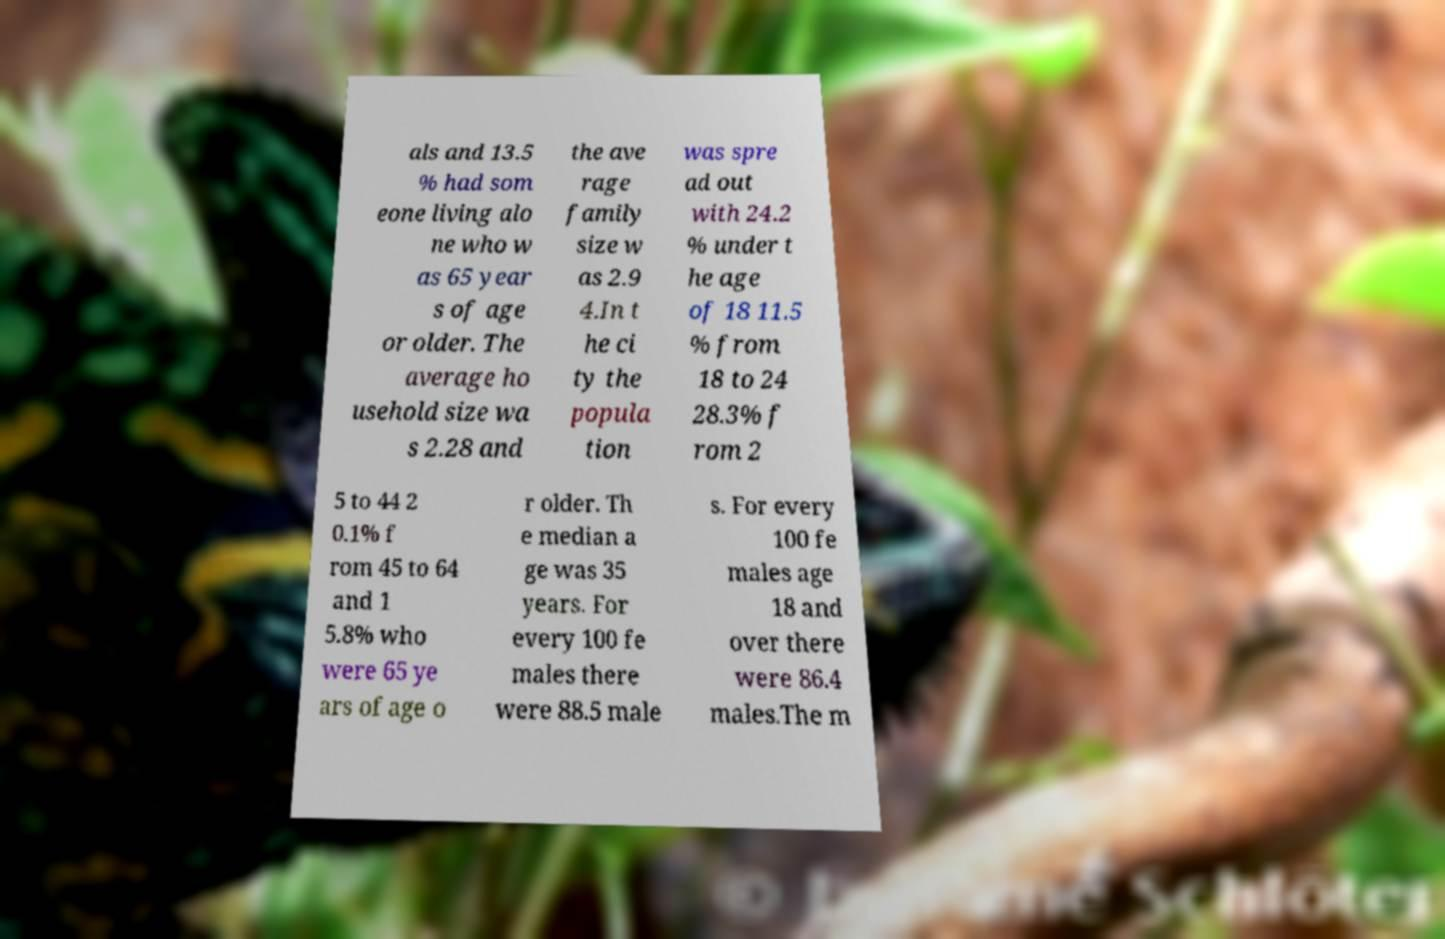Can you accurately transcribe the text from the provided image for me? als and 13.5 % had som eone living alo ne who w as 65 year s of age or older. The average ho usehold size wa s 2.28 and the ave rage family size w as 2.9 4.In t he ci ty the popula tion was spre ad out with 24.2 % under t he age of 18 11.5 % from 18 to 24 28.3% f rom 2 5 to 44 2 0.1% f rom 45 to 64 and 1 5.8% who were 65 ye ars of age o r older. Th e median a ge was 35 years. For every 100 fe males there were 88.5 male s. For every 100 fe males age 18 and over there were 86.4 males.The m 